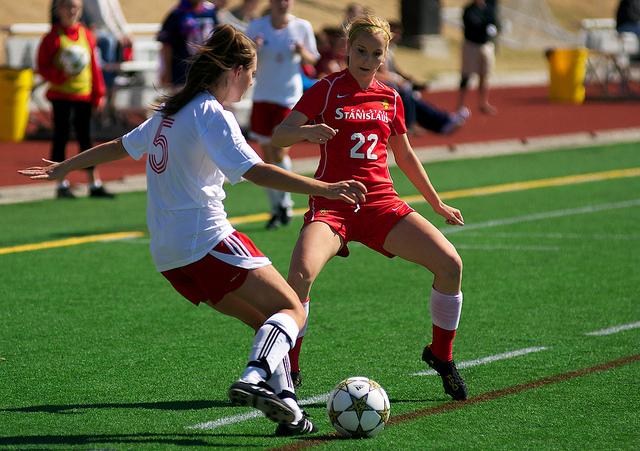Which girl has a red uniform?
Short answer required. Right. Is the girl in red trying to sit on the ball?
Keep it brief. No. What is the woman's Jersey number?
Quick response, please. 22. What type of surface are they playing on?
Short answer required. Grass. 